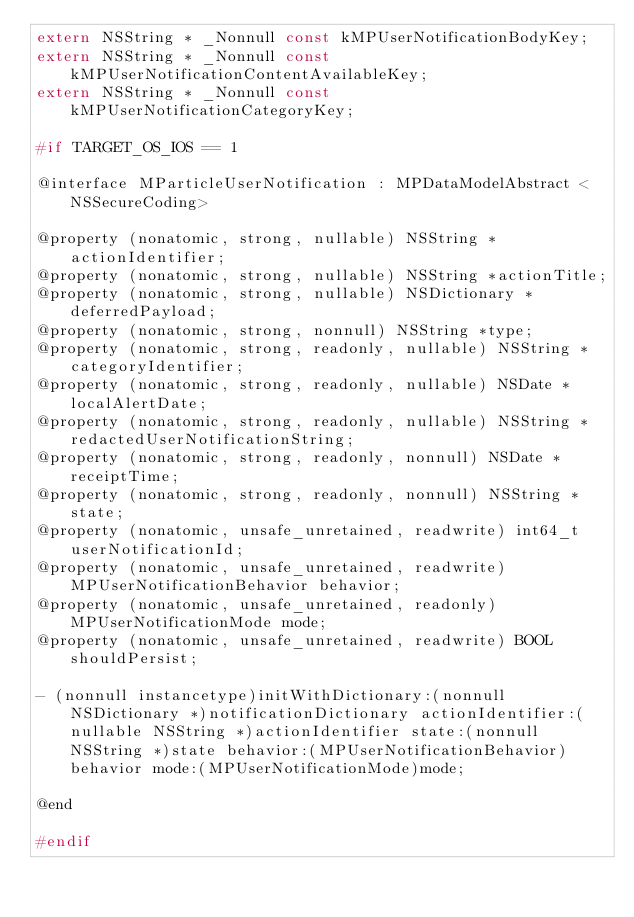<code> <loc_0><loc_0><loc_500><loc_500><_C_>extern NSString * _Nonnull const kMPUserNotificationBodyKey;
extern NSString * _Nonnull const kMPUserNotificationContentAvailableKey;
extern NSString * _Nonnull const kMPUserNotificationCategoryKey;

#if TARGET_OS_IOS == 1

@interface MParticleUserNotification : MPDataModelAbstract <NSSecureCoding>

@property (nonatomic, strong, nullable) NSString *actionIdentifier;
@property (nonatomic, strong, nullable) NSString *actionTitle;
@property (nonatomic, strong, nullable) NSDictionary *deferredPayload;
@property (nonatomic, strong, nonnull) NSString *type;
@property (nonatomic, strong, readonly, nullable) NSString *categoryIdentifier;
@property (nonatomic, strong, readonly, nullable) NSDate *localAlertDate;
@property (nonatomic, strong, readonly, nullable) NSString *redactedUserNotificationString;
@property (nonatomic, strong, readonly, nonnull) NSDate *receiptTime;
@property (nonatomic, strong, readonly, nonnull) NSString *state;
@property (nonatomic, unsafe_unretained, readwrite) int64_t userNotificationId;
@property (nonatomic, unsafe_unretained, readwrite) MPUserNotificationBehavior behavior;
@property (nonatomic, unsafe_unretained, readonly) MPUserNotificationMode mode;
@property (nonatomic, unsafe_unretained, readwrite) BOOL shouldPersist;

- (nonnull instancetype)initWithDictionary:(nonnull NSDictionary *)notificationDictionary actionIdentifier:(nullable NSString *)actionIdentifier state:(nonnull NSString *)state behavior:(MPUserNotificationBehavior)behavior mode:(MPUserNotificationMode)mode;

@end

#endif
</code> 